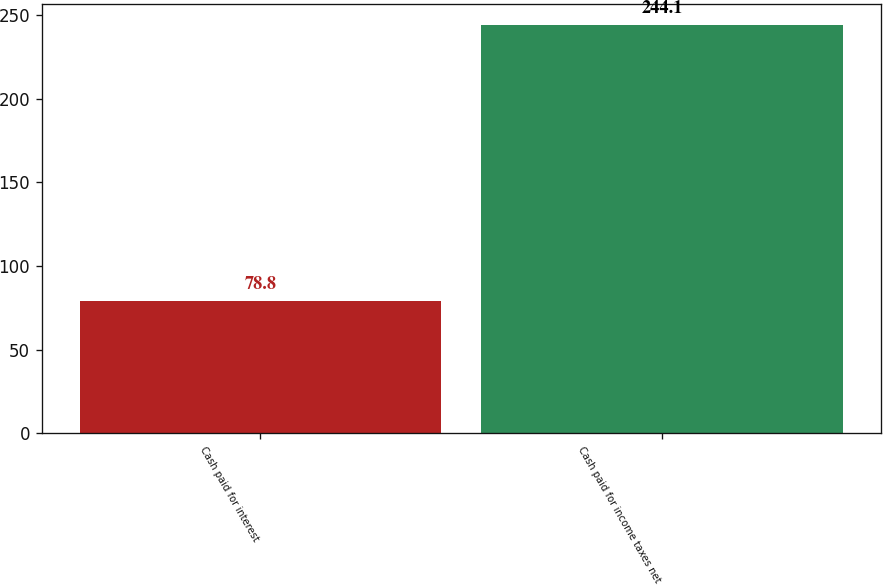<chart> <loc_0><loc_0><loc_500><loc_500><bar_chart><fcel>Cash paid for interest<fcel>Cash paid for income taxes net<nl><fcel>78.8<fcel>244.1<nl></chart> 